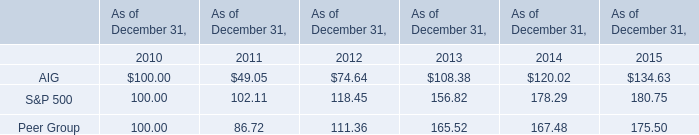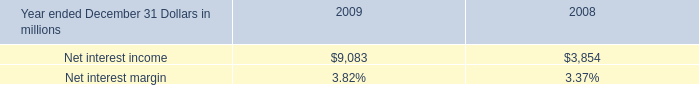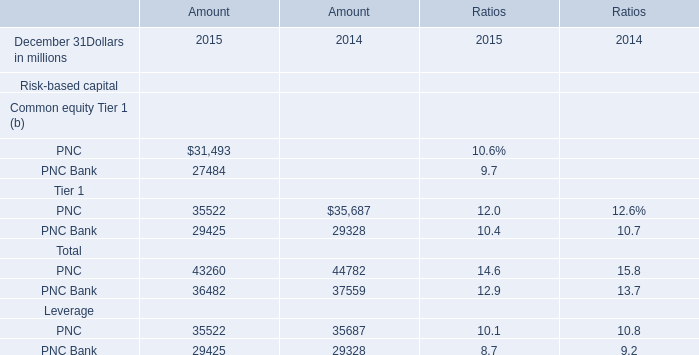what was the average net interest margin in% ( in % ) for 2009 and 2008.? 
Computations: ((3.82 + 3.37) / 2)
Answer: 3.595. 